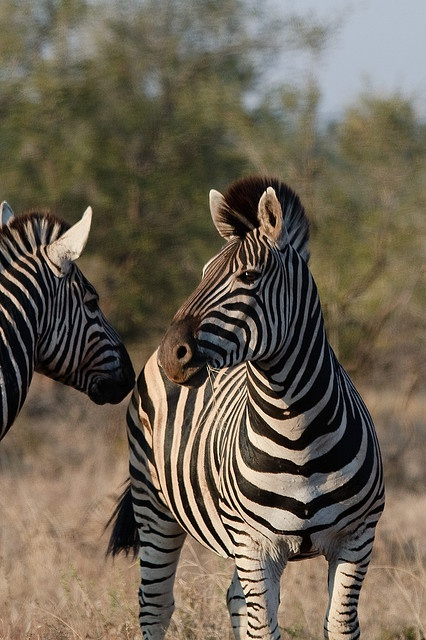Describe the objects in this image and their specific colors. I can see zebra in gray, black, and tan tones and zebra in gray, black, darkgray, and tan tones in this image. 